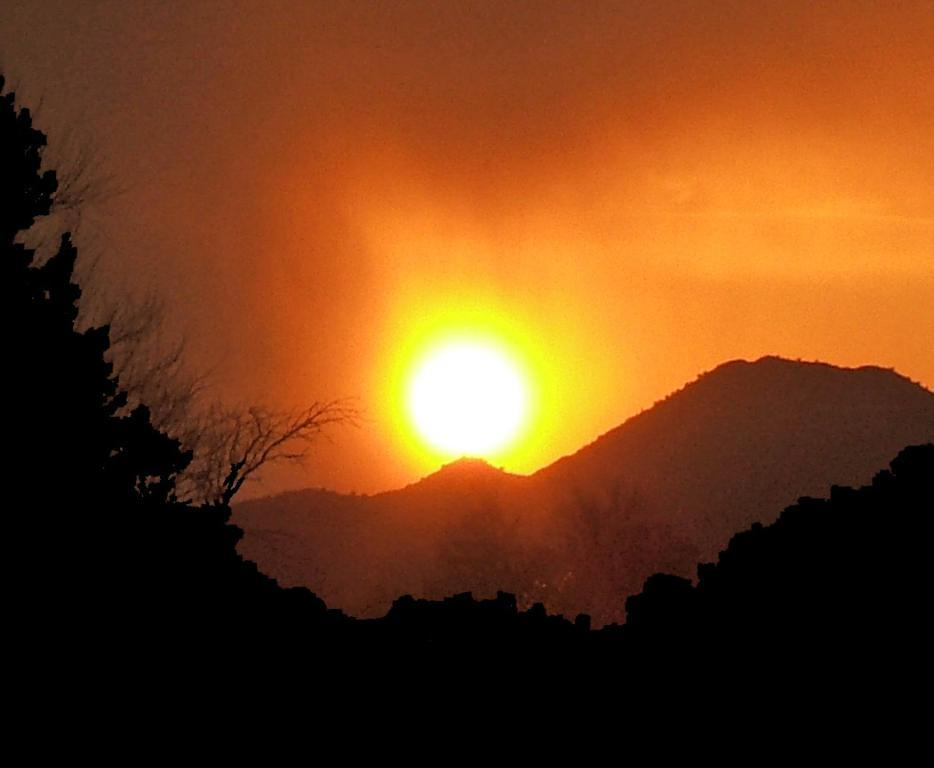What type of landscape feature can be seen in the image? There are hills in the image. What other natural elements are present in the image? There are trees in the image. What can be seen in the sky in the image? The sky is visible in the image, and the sun is also visible. Are there any pigs stuck in quicksand in the image? There are no pigs or quicksand present in the image. 